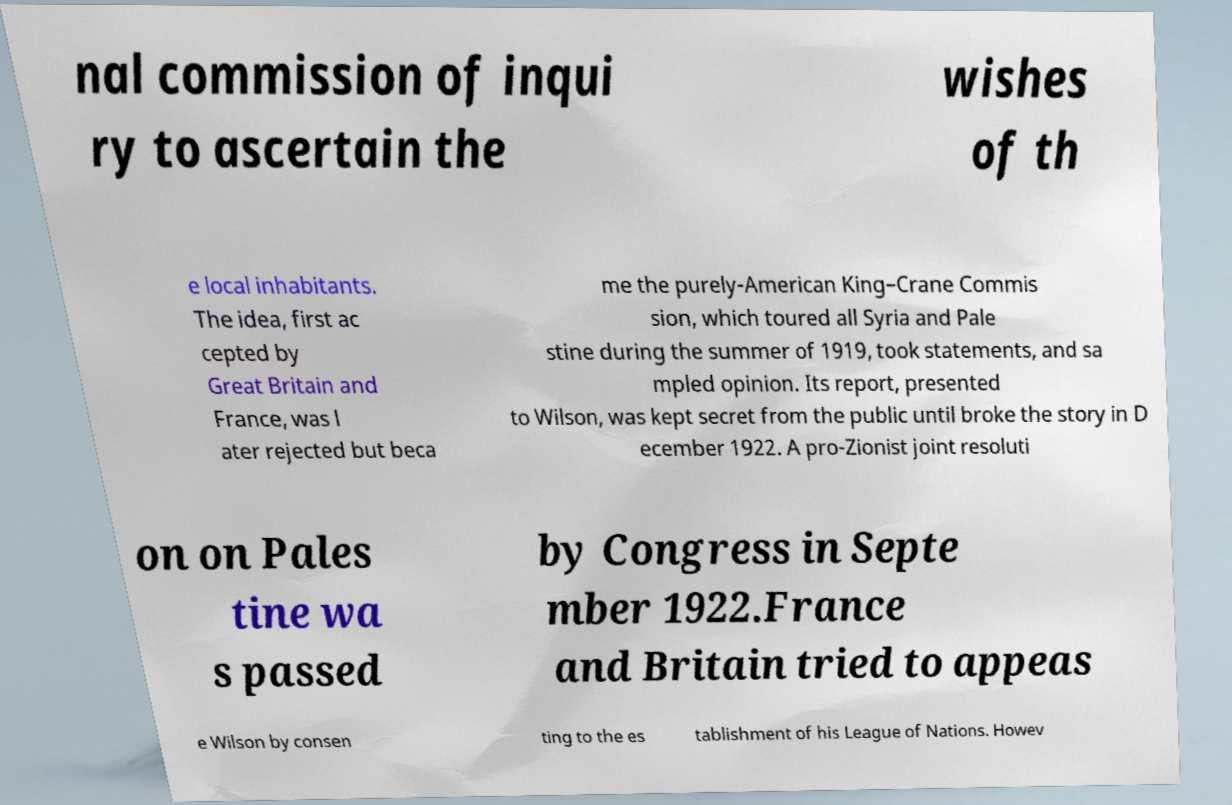For documentation purposes, I need the text within this image transcribed. Could you provide that? nal commission of inqui ry to ascertain the wishes of th e local inhabitants. The idea, first ac cepted by Great Britain and France, was l ater rejected but beca me the purely-American King–Crane Commis sion, which toured all Syria and Pale stine during the summer of 1919, took statements, and sa mpled opinion. Its report, presented to Wilson, was kept secret from the public until broke the story in D ecember 1922. A pro-Zionist joint resoluti on on Pales tine wa s passed by Congress in Septe mber 1922.France and Britain tried to appeas e Wilson by consen ting to the es tablishment of his League of Nations. Howev 